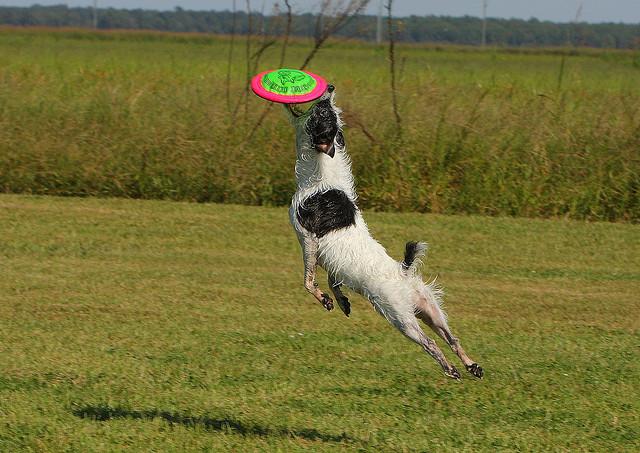Does the dog cast a shadow?
Quick response, please. Yes. Do you think the dog is enjoying playing frisbee?
Answer briefly. Yes. What is the dog holding in his mouth?
Write a very short answer. Frisbee. 